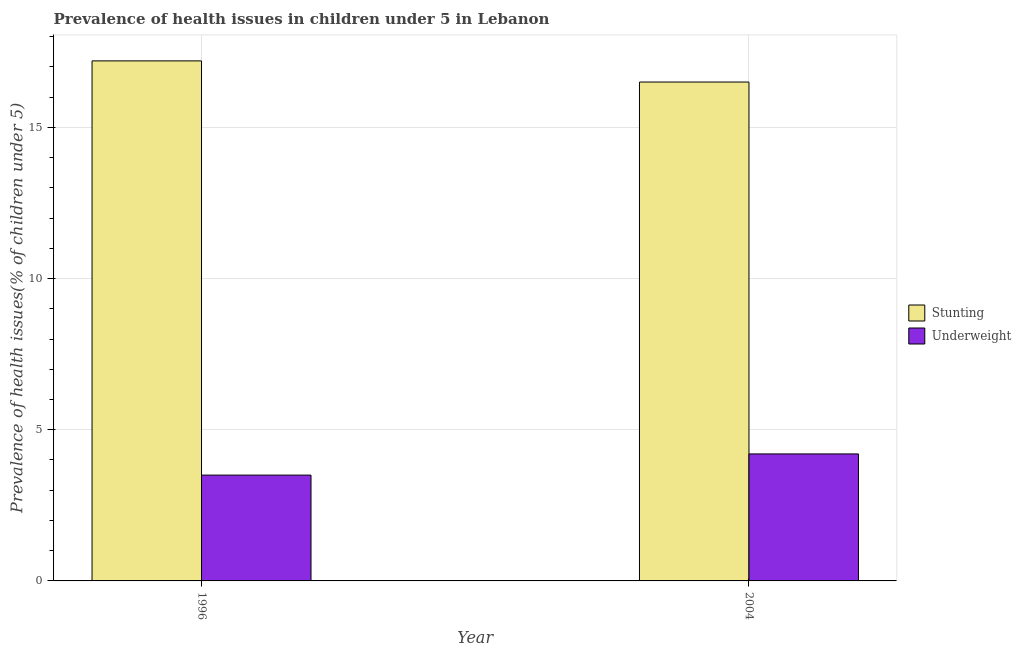How many different coloured bars are there?
Provide a succinct answer. 2. How many groups of bars are there?
Your answer should be very brief. 2. Are the number of bars per tick equal to the number of legend labels?
Offer a very short reply. Yes. Are the number of bars on each tick of the X-axis equal?
Provide a succinct answer. Yes. In how many cases, is the number of bars for a given year not equal to the number of legend labels?
Ensure brevity in your answer.  0. What is the percentage of stunted children in 1996?
Offer a very short reply. 17.2. Across all years, what is the maximum percentage of stunted children?
Offer a terse response. 17.2. In which year was the percentage of stunted children maximum?
Provide a short and direct response. 1996. What is the total percentage of underweight children in the graph?
Provide a succinct answer. 7.7. What is the difference between the percentage of underweight children in 1996 and that in 2004?
Keep it short and to the point. -0.7. What is the difference between the percentage of underweight children in 1996 and the percentage of stunted children in 2004?
Provide a succinct answer. -0.7. What is the average percentage of underweight children per year?
Keep it short and to the point. 3.85. In the year 2004, what is the difference between the percentage of underweight children and percentage of stunted children?
Give a very brief answer. 0. In how many years, is the percentage of stunted children greater than 9 %?
Offer a terse response. 2. What is the ratio of the percentage of underweight children in 1996 to that in 2004?
Offer a terse response. 0.83. Is the percentage of underweight children in 1996 less than that in 2004?
Make the answer very short. Yes. In how many years, is the percentage of stunted children greater than the average percentage of stunted children taken over all years?
Give a very brief answer. 1. What does the 2nd bar from the left in 2004 represents?
Your response must be concise. Underweight. What does the 2nd bar from the right in 1996 represents?
Your answer should be very brief. Stunting. How many bars are there?
Provide a short and direct response. 4. What is the difference between two consecutive major ticks on the Y-axis?
Your answer should be compact. 5. Are the values on the major ticks of Y-axis written in scientific E-notation?
Offer a terse response. No. Does the graph contain any zero values?
Your answer should be compact. No. How are the legend labels stacked?
Offer a terse response. Vertical. What is the title of the graph?
Provide a succinct answer. Prevalence of health issues in children under 5 in Lebanon. What is the label or title of the Y-axis?
Make the answer very short. Prevalence of health issues(% of children under 5). What is the Prevalence of health issues(% of children under 5) in Stunting in 1996?
Provide a short and direct response. 17.2. What is the Prevalence of health issues(% of children under 5) of Underweight in 2004?
Make the answer very short. 4.2. Across all years, what is the maximum Prevalence of health issues(% of children under 5) in Stunting?
Provide a short and direct response. 17.2. Across all years, what is the maximum Prevalence of health issues(% of children under 5) of Underweight?
Your answer should be compact. 4.2. Across all years, what is the minimum Prevalence of health issues(% of children under 5) in Stunting?
Your answer should be compact. 16.5. Across all years, what is the minimum Prevalence of health issues(% of children under 5) in Underweight?
Your response must be concise. 3.5. What is the total Prevalence of health issues(% of children under 5) of Stunting in the graph?
Provide a short and direct response. 33.7. What is the difference between the Prevalence of health issues(% of children under 5) in Underweight in 1996 and that in 2004?
Keep it short and to the point. -0.7. What is the difference between the Prevalence of health issues(% of children under 5) of Stunting in 1996 and the Prevalence of health issues(% of children under 5) of Underweight in 2004?
Ensure brevity in your answer.  13. What is the average Prevalence of health issues(% of children under 5) of Stunting per year?
Offer a terse response. 16.85. What is the average Prevalence of health issues(% of children under 5) of Underweight per year?
Offer a very short reply. 3.85. In the year 1996, what is the difference between the Prevalence of health issues(% of children under 5) in Stunting and Prevalence of health issues(% of children under 5) in Underweight?
Keep it short and to the point. 13.7. What is the ratio of the Prevalence of health issues(% of children under 5) in Stunting in 1996 to that in 2004?
Your response must be concise. 1.04. What is the ratio of the Prevalence of health issues(% of children under 5) of Underweight in 1996 to that in 2004?
Make the answer very short. 0.83. What is the difference between the highest and the second highest Prevalence of health issues(% of children under 5) in Underweight?
Provide a short and direct response. 0.7. What is the difference between the highest and the lowest Prevalence of health issues(% of children under 5) of Underweight?
Ensure brevity in your answer.  0.7. 